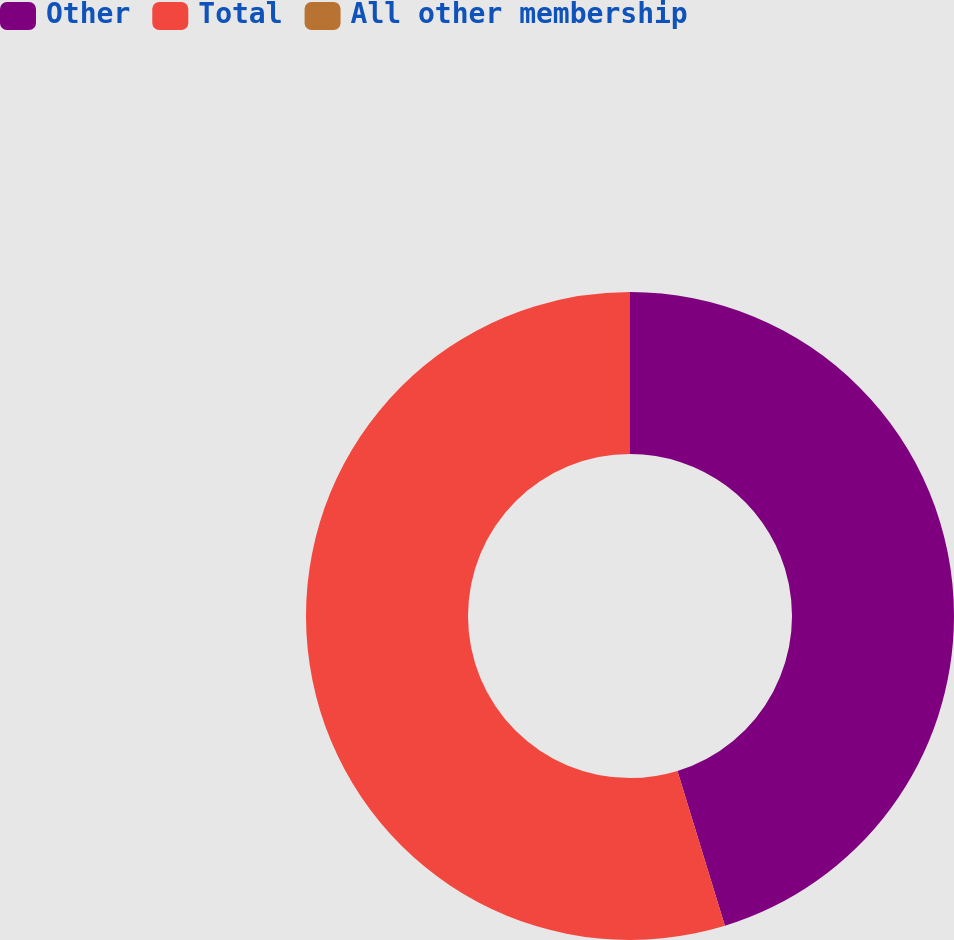Convert chart to OTSL. <chart><loc_0><loc_0><loc_500><loc_500><pie_chart><fcel>Other<fcel>Total<fcel>All other membership<nl><fcel>45.27%<fcel>54.73%<fcel>0.0%<nl></chart> 